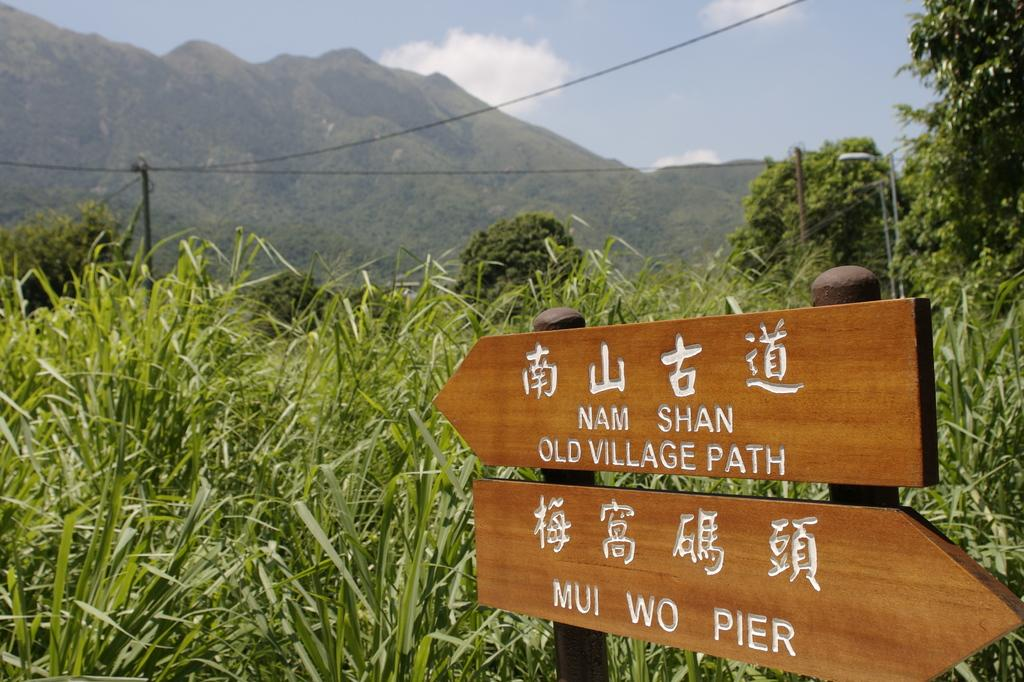What type of vegetation can be seen in the image? There is grass in the image. What structures are present in the image? There are boards and poles in the image. What natural features can be seen in the image? There are trees and a mountain in the image. What is visible in the background of the image? The sky is visible in the background of the image, and there are clouds in the sky. What type of animals can be seen in the zoo in the image? There is no zoo present in the image, so it is not possible to determine what animals might be seen. 